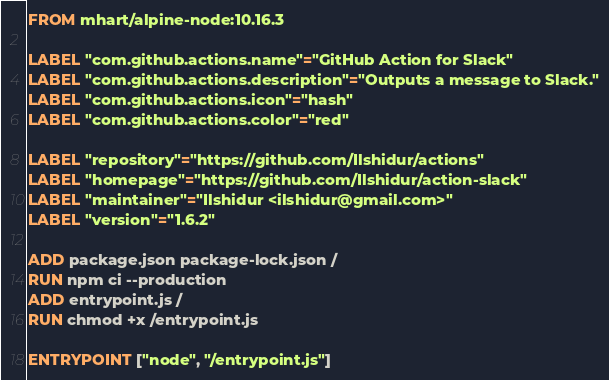Convert code to text. <code><loc_0><loc_0><loc_500><loc_500><_Dockerfile_>FROM mhart/alpine-node:10.16.3

LABEL "com.github.actions.name"="GitHub Action for Slack"
LABEL "com.github.actions.description"="Outputs a message to Slack."
LABEL "com.github.actions.icon"="hash"
LABEL "com.github.actions.color"="red"

LABEL "repository"="https://github.com/Ilshidur/actions"
LABEL "homepage"="https://github.com/Ilshidur/action-slack"
LABEL "maintainer"="Ilshidur <ilshidur@gmail.com>"
LABEL "version"="1.6.2"

ADD package.json package-lock.json /
RUN npm ci --production
ADD entrypoint.js /
RUN chmod +x /entrypoint.js

ENTRYPOINT ["node", "/entrypoint.js"]
</code> 